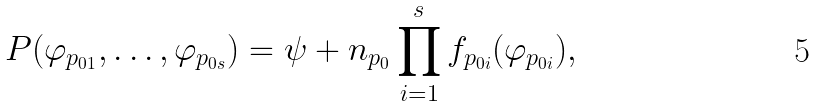Convert formula to latex. <formula><loc_0><loc_0><loc_500><loc_500>P ( \varphi _ { p _ { 0 1 } } , \dots , \varphi _ { p _ { 0 s } } ) = \psi + n _ { p _ { 0 } } \prod _ { i = 1 } ^ { s } f _ { p _ { 0 i } } ( \varphi _ { p _ { 0 i } } ) ,</formula> 